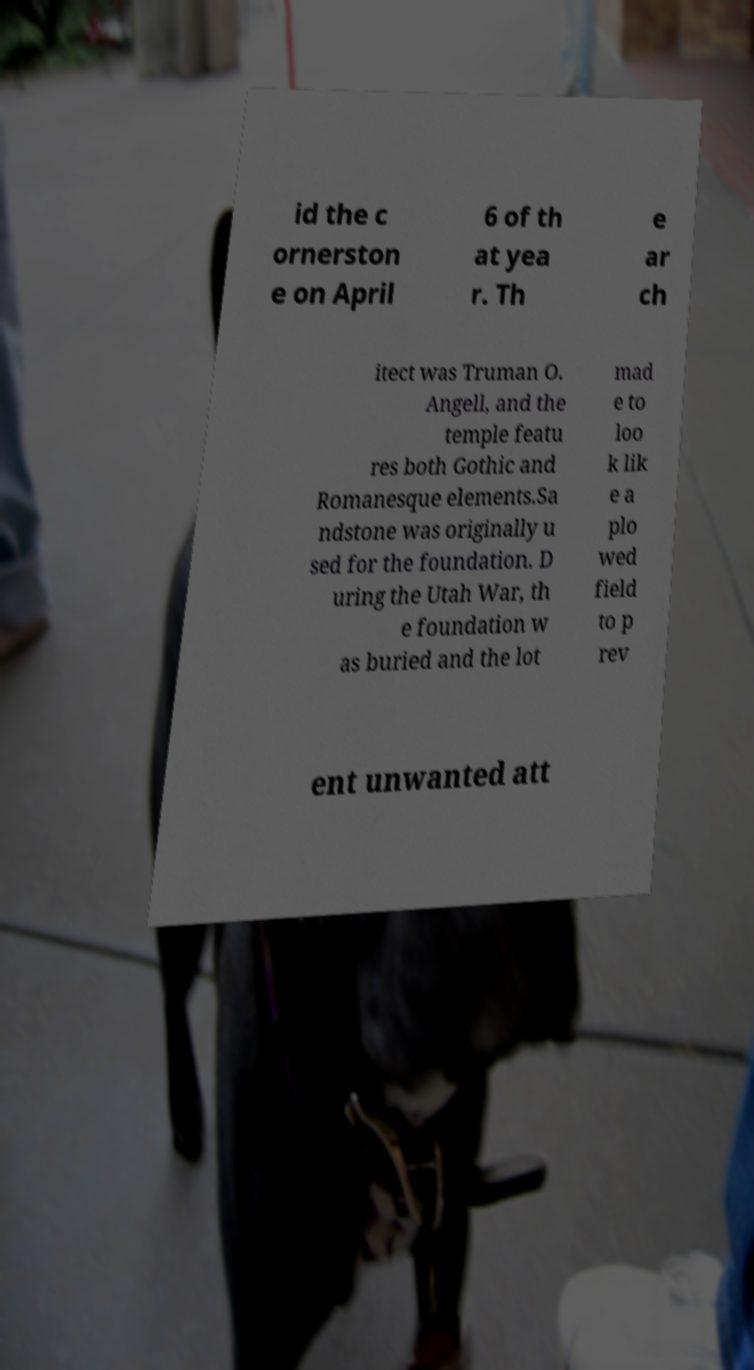There's text embedded in this image that I need extracted. Can you transcribe it verbatim? id the c ornerston e on April 6 of th at yea r. Th e ar ch itect was Truman O. Angell, and the temple featu res both Gothic and Romanesque elements.Sa ndstone was originally u sed for the foundation. D uring the Utah War, th e foundation w as buried and the lot mad e to loo k lik e a plo wed field to p rev ent unwanted att 